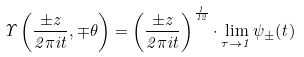<formula> <loc_0><loc_0><loc_500><loc_500>\Upsilon \left ( \frac { \pm z } { 2 \pi i t } , \mp \theta \right ) = \left ( \frac { \pm z } { 2 \pi i t } \right ) ^ { \frac { 1 } { 1 2 } } \cdot \lim _ { \tau \to 1 } \psi _ { \pm } ( t )</formula> 